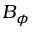Convert formula to latex. <formula><loc_0><loc_0><loc_500><loc_500>B _ { \phi }</formula> 